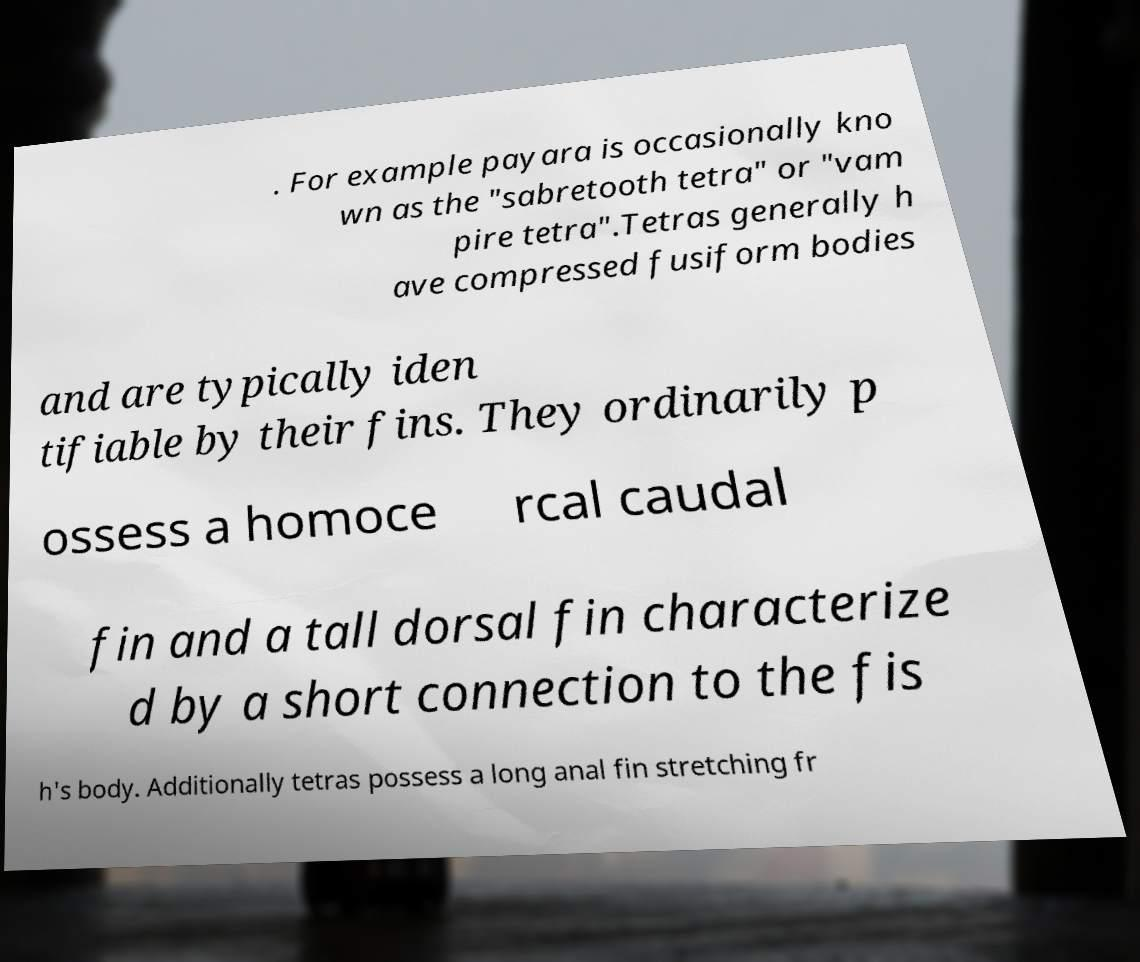Can you read and provide the text displayed in the image?This photo seems to have some interesting text. Can you extract and type it out for me? . For example payara is occasionally kno wn as the "sabretooth tetra" or "vam pire tetra".Tetras generally h ave compressed fusiform bodies and are typically iden tifiable by their fins. They ordinarily p ossess a homoce rcal caudal fin and a tall dorsal fin characterize d by a short connection to the fis h's body. Additionally tetras possess a long anal fin stretching fr 